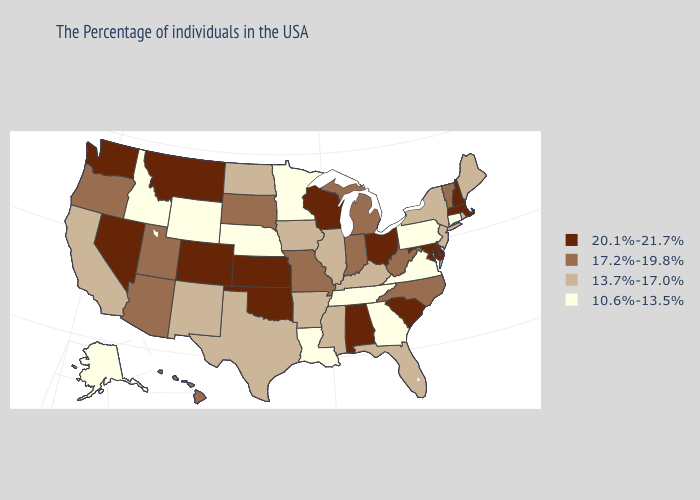Does Utah have the highest value in the USA?
Quick response, please. No. Does Nevada have a higher value than Utah?
Quick response, please. Yes. Does Florida have the lowest value in the USA?
Be succinct. No. Which states have the lowest value in the USA?
Answer briefly. Connecticut, Pennsylvania, Virginia, Georgia, Tennessee, Louisiana, Minnesota, Nebraska, Wyoming, Idaho, Alaska. Among the states that border Indiana , does Ohio have the highest value?
Concise answer only. Yes. Name the states that have a value in the range 17.2%-19.8%?
Short answer required. Vermont, North Carolina, West Virginia, Michigan, Indiana, Missouri, South Dakota, Utah, Arizona, Oregon, Hawaii. Name the states that have a value in the range 13.7%-17.0%?
Keep it brief. Maine, Rhode Island, New York, New Jersey, Florida, Kentucky, Illinois, Mississippi, Arkansas, Iowa, Texas, North Dakota, New Mexico, California. Does Florida have a higher value than Washington?
Short answer required. No. Among the states that border Oregon , which have the highest value?
Be succinct. Nevada, Washington. Which states have the highest value in the USA?
Give a very brief answer. Massachusetts, New Hampshire, Delaware, Maryland, South Carolina, Ohio, Alabama, Wisconsin, Kansas, Oklahoma, Colorado, Montana, Nevada, Washington. Name the states that have a value in the range 10.6%-13.5%?
Concise answer only. Connecticut, Pennsylvania, Virginia, Georgia, Tennessee, Louisiana, Minnesota, Nebraska, Wyoming, Idaho, Alaska. What is the lowest value in the USA?
Answer briefly. 10.6%-13.5%. Among the states that border Arkansas , does Louisiana have the lowest value?
Quick response, please. Yes. Which states have the highest value in the USA?
Be succinct. Massachusetts, New Hampshire, Delaware, Maryland, South Carolina, Ohio, Alabama, Wisconsin, Kansas, Oklahoma, Colorado, Montana, Nevada, Washington. Does Connecticut have the lowest value in the Northeast?
Write a very short answer. Yes. 